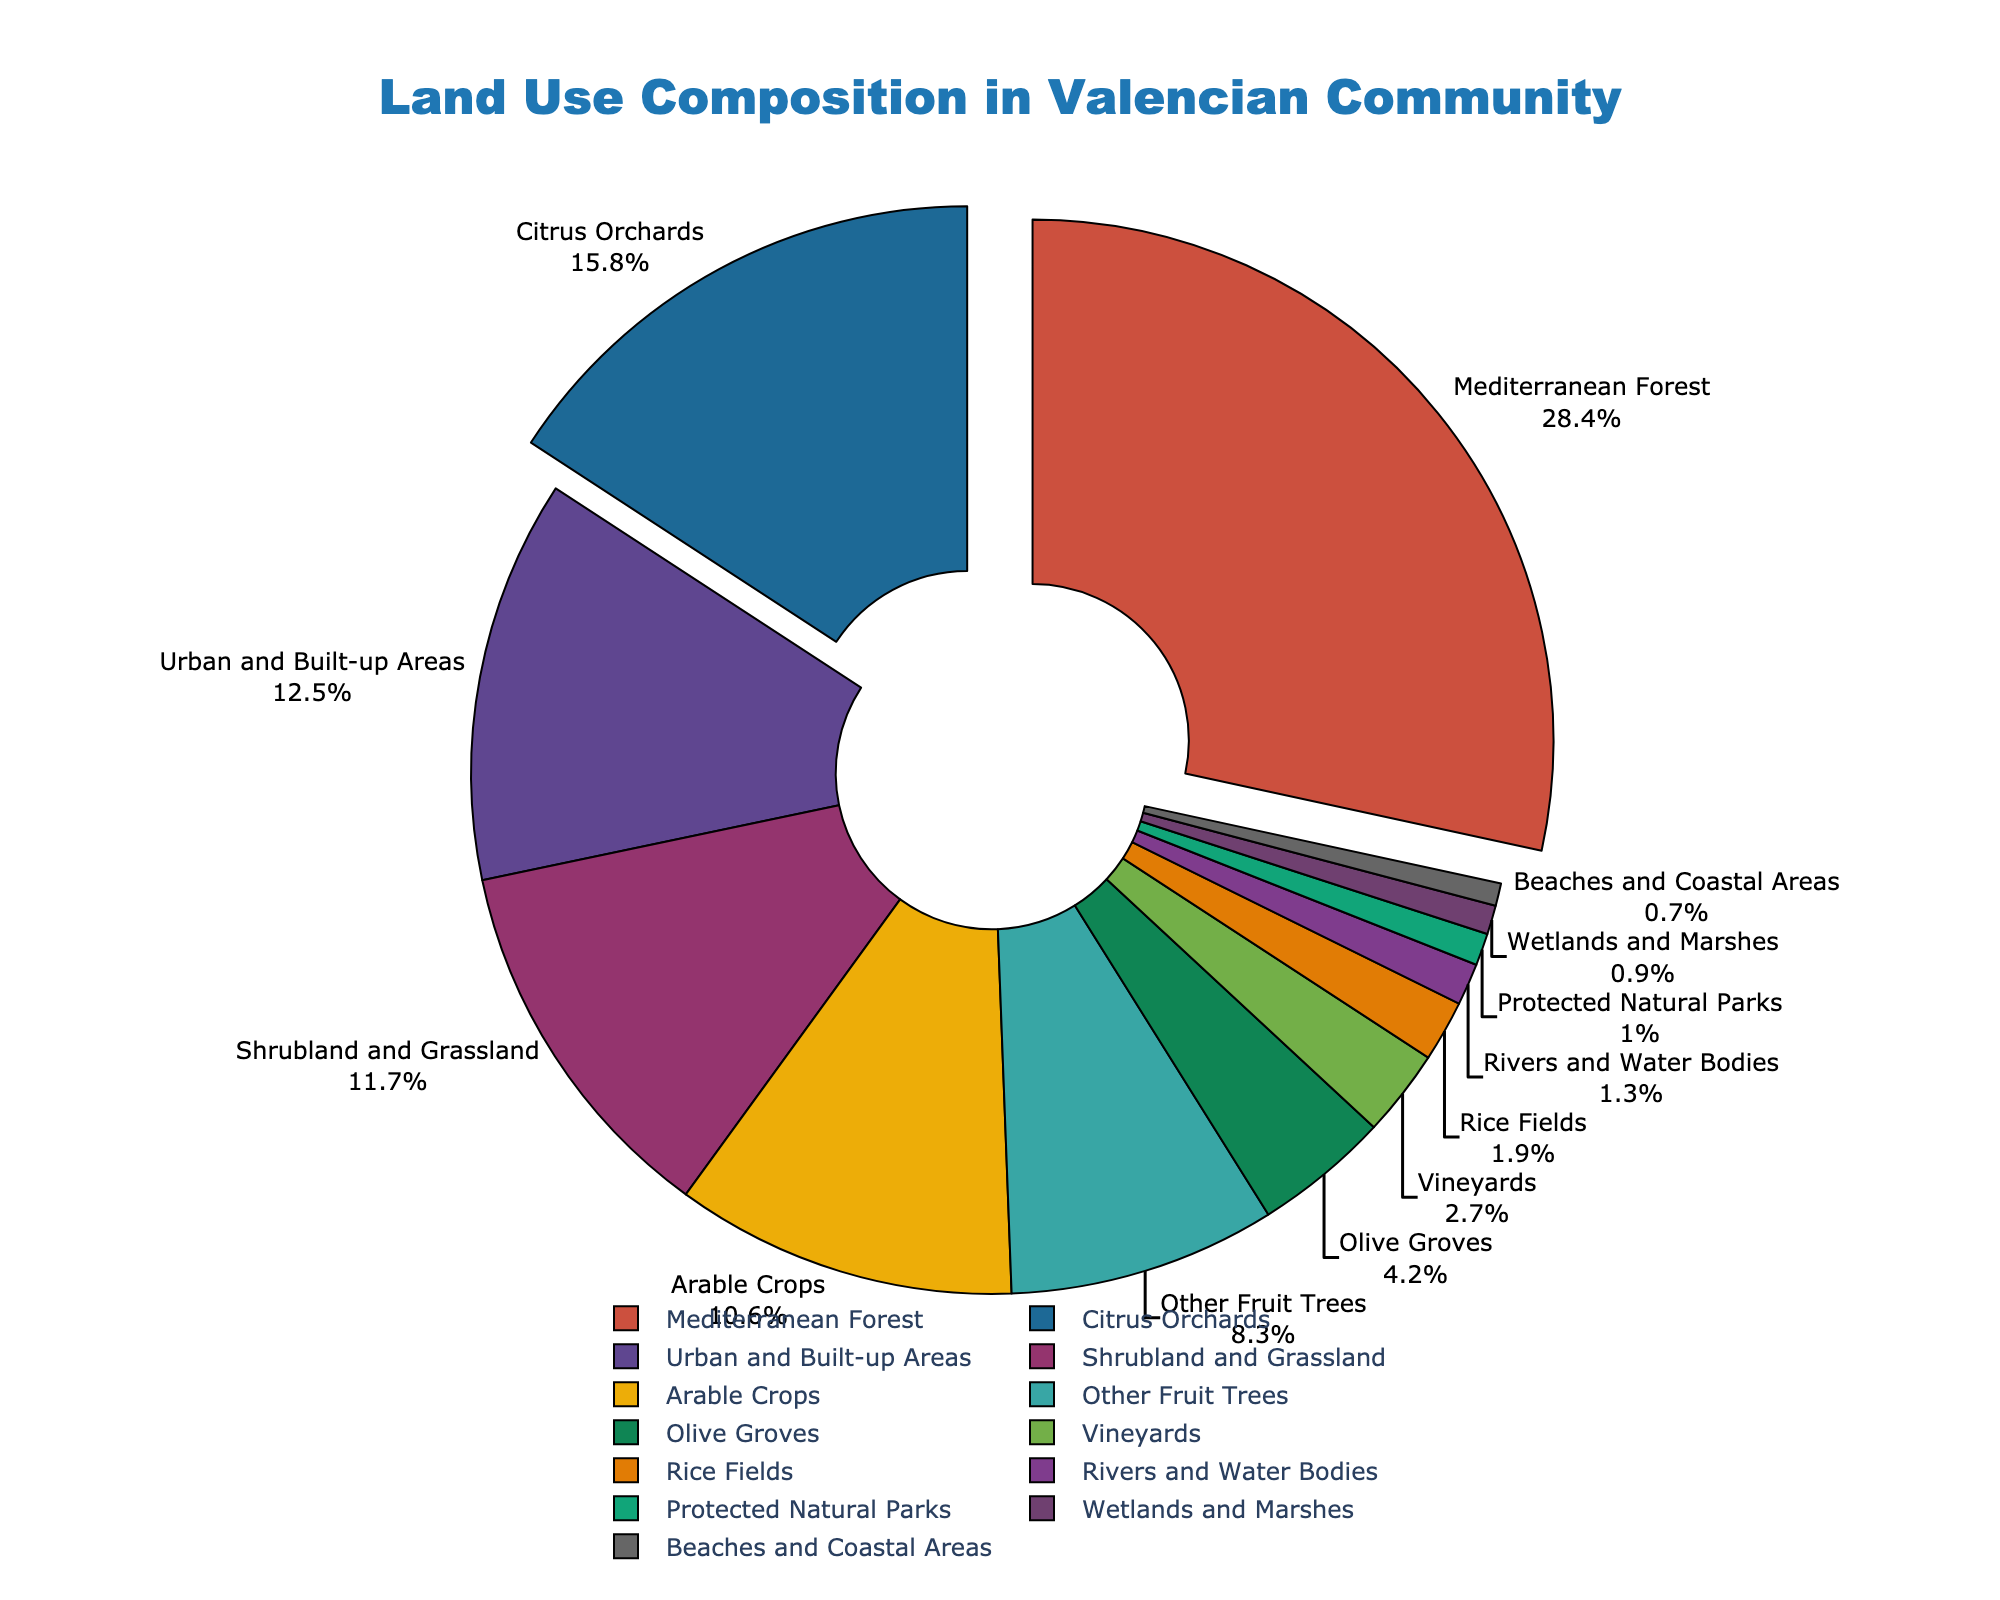What is the largest land use category? By observing the figure, identify the segment that represents the largest land use percentage. "Mediterranean Forest" makes up 28.4%, which is the highest.
Answer: Mediterranean Forest What is the combined percentage of Citrus Orchards and Arable Crops? Sum the percentages of Citrus Orchards (15.8%) and Arable Crops (10.6%). The total is 15.8 + 10.6 = 26.4%.
Answer: 26.4% Which land use type has a larger area: Olive Groves or Rivers and Water Bodies? Compare the percentages of Olive Groves (4.2%) and Rivers and Water Bodies (1.3%), noting that 4.2% > 1.3%.
Answer: Olive Groves How much larger is the area of Shrubland and Grassland compared to Vineyards? Subtract the percentage of Vineyards (2.7%) from the percentage of Shrubland and Grassland (11.7%). The difference is 11.7 - 2.7 = 9%.
Answer: 9% What is the median percentage of land use categories based on the figure? Arrange the percentages in ascending order and find the middle value. The values are: 0.7, 0.9, 1.0, 1.3, 1.9, 2.7, 4.2, 8.3, 10.6, 11.7, 12.5, 15.8, 28.4. The median (middle) value is 8.3%.
Answer: 8.3% Which land use type makes up less than 1% of the total area? By observing the labels and their corresponding percentages, identify "Beaches and Coastal Areas" at 0.7%, and "Wetlands and Marshes" at 0.9%. Both categories are less than 1%.
Answer: Beaches and Coastal Areas, Wetlands and Marshes Among the categories pulled out from the pie chart, which has the highest percentage? Notice which sectors are pulled out (those with percentages greater than 15%). "Mediterranean Forest" (28.4%) and "Citrus Orchards" (15.8%) are pulled out. "Mediterranean Forest" has the highest percentage.
Answer: Mediterranean Forest What fraction of the land area is covered by urban and built-up areas? Refer to the chart where "Urban and Built-up Areas" makes up 12.5% of the total. Therefore, the fraction is 12.5/100 = 0.125.
Answer: 0.125 Estimate how much of the land is dedicated to Rice Fields? Identify the "Rice Fields" section in the chart, which represents 1.9% of the total land use.
Answer: 1.9% Is the area covered by Protected Natural Parks more or less than Rivers and Water Bodies? Compare the percentages for Protected Natural Parks (1.0%) and Rivers and Water Bodies (1.3%). Since 1.0% < 1.3%, the area covered by Protected Natural Parks is less.
Answer: Less 